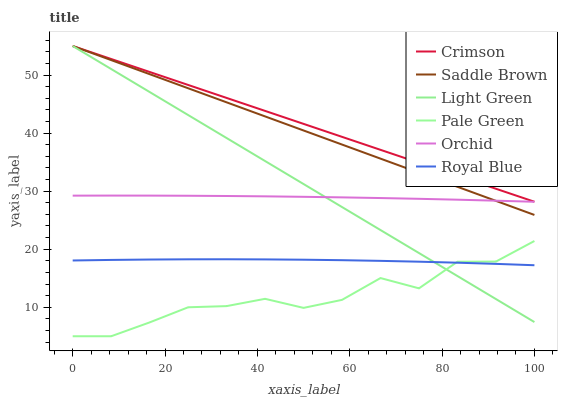Does Pale Green have the minimum area under the curve?
Answer yes or no. Yes. Does Crimson have the maximum area under the curve?
Answer yes or no. Yes. Does Light Green have the minimum area under the curve?
Answer yes or no. No. Does Light Green have the maximum area under the curve?
Answer yes or no. No. Is Light Green the smoothest?
Answer yes or no. Yes. Is Pale Green the roughest?
Answer yes or no. Yes. Is Pale Green the smoothest?
Answer yes or no. No. Is Light Green the roughest?
Answer yes or no. No. Does Pale Green have the lowest value?
Answer yes or no. Yes. Does Light Green have the lowest value?
Answer yes or no. No. Does Saddle Brown have the highest value?
Answer yes or no. Yes. Does Pale Green have the highest value?
Answer yes or no. No. Is Royal Blue less than Saddle Brown?
Answer yes or no. Yes. Is Orchid greater than Pale Green?
Answer yes or no. Yes. Does Orchid intersect Saddle Brown?
Answer yes or no. Yes. Is Orchid less than Saddle Brown?
Answer yes or no. No. Is Orchid greater than Saddle Brown?
Answer yes or no. No. Does Royal Blue intersect Saddle Brown?
Answer yes or no. No. 